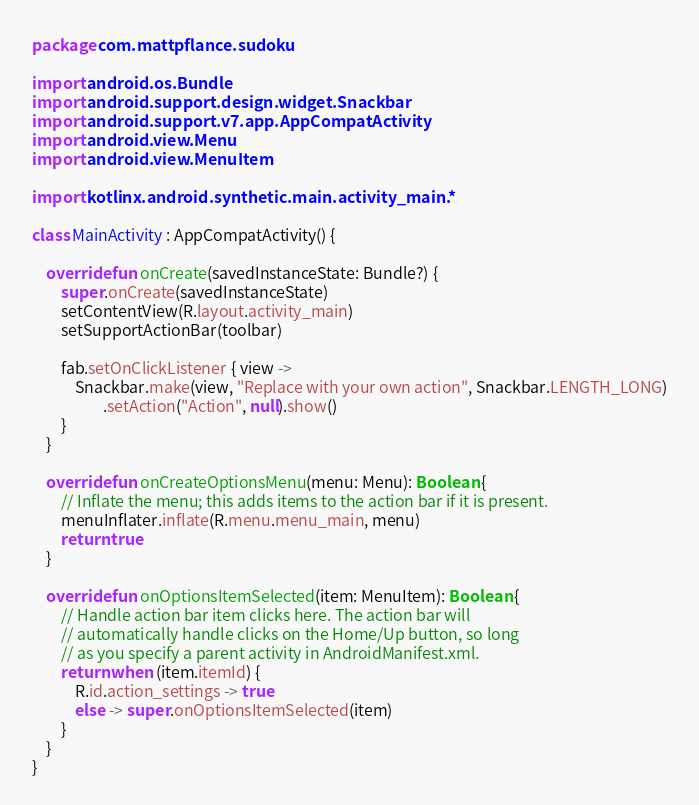<code> <loc_0><loc_0><loc_500><loc_500><_Kotlin_>package com.mattpflance.sudoku

import android.os.Bundle
import android.support.design.widget.Snackbar
import android.support.v7.app.AppCompatActivity
import android.view.Menu
import android.view.MenuItem

import kotlinx.android.synthetic.main.activity_main.*

class MainActivity : AppCompatActivity() {

    override fun onCreate(savedInstanceState: Bundle?) {
        super.onCreate(savedInstanceState)
        setContentView(R.layout.activity_main)
        setSupportActionBar(toolbar)

        fab.setOnClickListener { view ->
            Snackbar.make(view, "Replace with your own action", Snackbar.LENGTH_LONG)
                    .setAction("Action", null).show()
        }
    }

    override fun onCreateOptionsMenu(menu: Menu): Boolean {
        // Inflate the menu; this adds items to the action bar if it is present.
        menuInflater.inflate(R.menu.menu_main, menu)
        return true
    }

    override fun onOptionsItemSelected(item: MenuItem): Boolean {
        // Handle action bar item clicks here. The action bar will
        // automatically handle clicks on the Home/Up button, so long
        // as you specify a parent activity in AndroidManifest.xml.
        return when (item.itemId) {
            R.id.action_settings -> true
            else -> super.onOptionsItemSelected(item)
        }
    }
}
</code> 